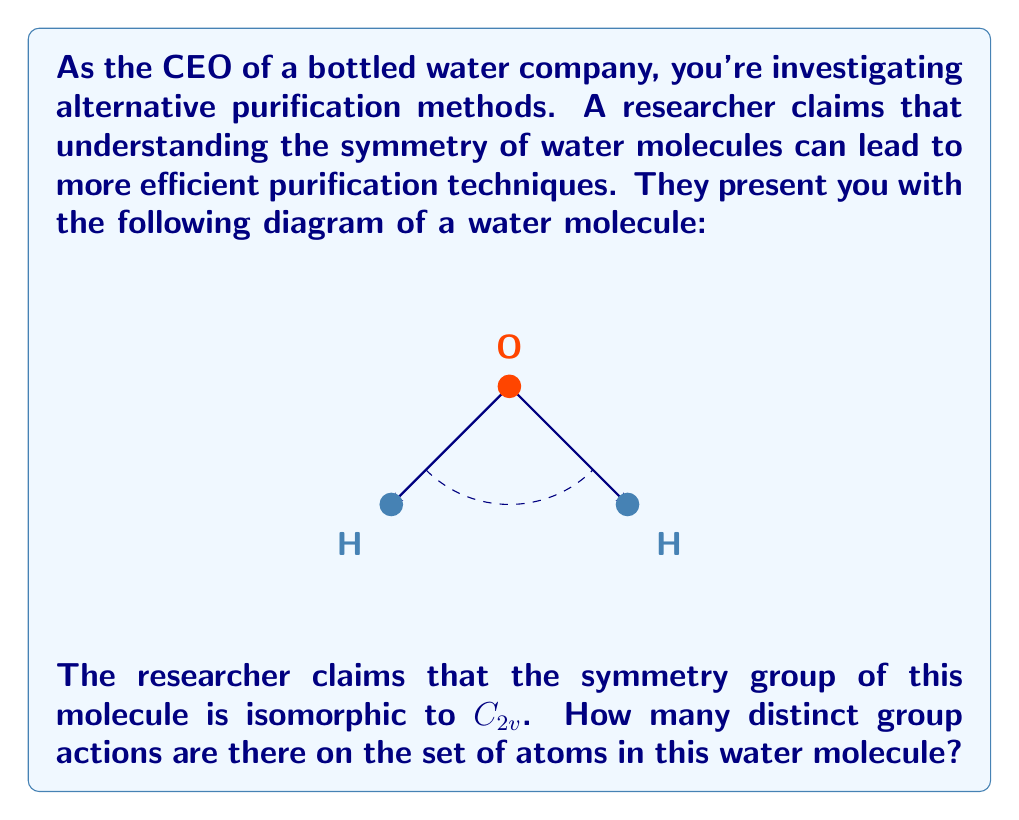Show me your answer to this math problem. Let's approach this step-by-step:

1) First, we need to understand what $C_{2v}$ means. It's the symmetry group of a water molecule, which consists of:
   - The identity operation (E)
   - A 180-degree rotation around the bisector of the H-O-H angle (C2)
   - Two reflection operations (σv and σv')

2) The set of atoms in a water molecule consists of 3 elements: {O, H1, H2}

3) A group action is a function $\phi: G \times X \rightarrow X$ where G is the group and X is the set being acted upon. In this case, G = $C_{2v}$ and X = {O, H1, H2}

4) To count the number of distinct group actions, we need to count the number of distinct homomorphisms from $C_{2v}$ to $S_3$ (the symmetric group on 3 elements)

5) In a valid homomorphism:
   - The identity element of $C_{2v}$ must map to the identity permutation in $S_3$
   - The order of each element must be preserved

6) The possible mappings for the non-identity elements of $C_{2v}$ are:
   - C2 must map to a 2-cycle (transposition) in $S_3$
   - σv and σv' can each map to either a 2-cycle or the identity

7) This gives us 3 possible homomorphisms:
   - C2 → (12), σv → (12), σv' → (12)
   - C2 → (12), σv → (12), σv' → ()
   - C2 → (12), σv → (), σv' → (12)

Therefore, there are 3 distinct group actions of $C_{2v}$ on the set of atoms in a water molecule.
Answer: 3 